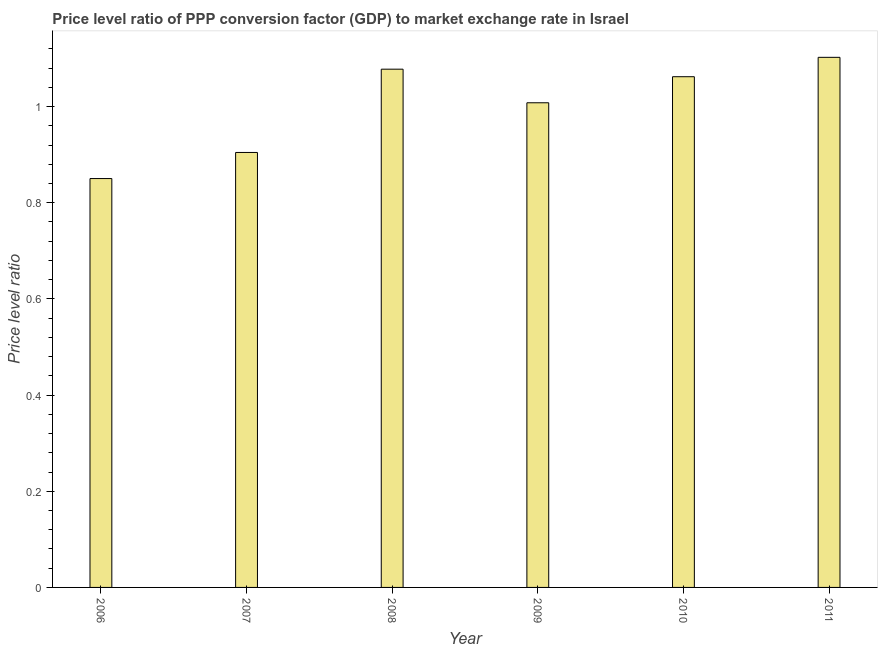Does the graph contain grids?
Provide a succinct answer. No. What is the title of the graph?
Give a very brief answer. Price level ratio of PPP conversion factor (GDP) to market exchange rate in Israel. What is the label or title of the Y-axis?
Give a very brief answer. Price level ratio. What is the price level ratio in 2009?
Offer a terse response. 1.01. Across all years, what is the maximum price level ratio?
Offer a terse response. 1.1. Across all years, what is the minimum price level ratio?
Your answer should be compact. 0.85. In which year was the price level ratio minimum?
Offer a very short reply. 2006. What is the sum of the price level ratio?
Ensure brevity in your answer.  6.01. What is the difference between the price level ratio in 2009 and 2011?
Your answer should be very brief. -0.1. What is the median price level ratio?
Offer a very short reply. 1.04. Do a majority of the years between 2009 and 2007 (inclusive) have price level ratio greater than 1 ?
Provide a short and direct response. Yes. What is the ratio of the price level ratio in 2006 to that in 2009?
Give a very brief answer. 0.84. Is the price level ratio in 2008 less than that in 2009?
Offer a terse response. No. Is the difference between the price level ratio in 2008 and 2011 greater than the difference between any two years?
Keep it short and to the point. No. What is the difference between the highest and the second highest price level ratio?
Provide a short and direct response. 0.03. What is the difference between the highest and the lowest price level ratio?
Make the answer very short. 0.25. How many bars are there?
Ensure brevity in your answer.  6. What is the difference between two consecutive major ticks on the Y-axis?
Offer a terse response. 0.2. What is the Price level ratio of 2006?
Offer a terse response. 0.85. What is the Price level ratio of 2007?
Give a very brief answer. 0.9. What is the Price level ratio in 2008?
Provide a short and direct response. 1.08. What is the Price level ratio in 2009?
Keep it short and to the point. 1.01. What is the Price level ratio in 2010?
Make the answer very short. 1.06. What is the Price level ratio in 2011?
Your answer should be very brief. 1.1. What is the difference between the Price level ratio in 2006 and 2007?
Make the answer very short. -0.05. What is the difference between the Price level ratio in 2006 and 2008?
Offer a very short reply. -0.23. What is the difference between the Price level ratio in 2006 and 2009?
Ensure brevity in your answer.  -0.16. What is the difference between the Price level ratio in 2006 and 2010?
Your answer should be very brief. -0.21. What is the difference between the Price level ratio in 2006 and 2011?
Provide a succinct answer. -0.25. What is the difference between the Price level ratio in 2007 and 2008?
Your response must be concise. -0.17. What is the difference between the Price level ratio in 2007 and 2009?
Provide a succinct answer. -0.1. What is the difference between the Price level ratio in 2007 and 2010?
Give a very brief answer. -0.16. What is the difference between the Price level ratio in 2007 and 2011?
Offer a terse response. -0.2. What is the difference between the Price level ratio in 2008 and 2009?
Ensure brevity in your answer.  0.07. What is the difference between the Price level ratio in 2008 and 2010?
Keep it short and to the point. 0.02. What is the difference between the Price level ratio in 2008 and 2011?
Offer a terse response. -0.02. What is the difference between the Price level ratio in 2009 and 2010?
Give a very brief answer. -0.05. What is the difference between the Price level ratio in 2009 and 2011?
Your response must be concise. -0.09. What is the difference between the Price level ratio in 2010 and 2011?
Make the answer very short. -0.04. What is the ratio of the Price level ratio in 2006 to that in 2007?
Provide a succinct answer. 0.94. What is the ratio of the Price level ratio in 2006 to that in 2008?
Provide a succinct answer. 0.79. What is the ratio of the Price level ratio in 2006 to that in 2009?
Ensure brevity in your answer.  0.84. What is the ratio of the Price level ratio in 2006 to that in 2010?
Ensure brevity in your answer.  0.8. What is the ratio of the Price level ratio in 2006 to that in 2011?
Keep it short and to the point. 0.77. What is the ratio of the Price level ratio in 2007 to that in 2008?
Provide a succinct answer. 0.84. What is the ratio of the Price level ratio in 2007 to that in 2009?
Ensure brevity in your answer.  0.9. What is the ratio of the Price level ratio in 2007 to that in 2010?
Your answer should be very brief. 0.85. What is the ratio of the Price level ratio in 2007 to that in 2011?
Make the answer very short. 0.82. What is the ratio of the Price level ratio in 2008 to that in 2009?
Ensure brevity in your answer.  1.07. What is the ratio of the Price level ratio in 2008 to that in 2010?
Your answer should be compact. 1.01. What is the ratio of the Price level ratio in 2008 to that in 2011?
Your answer should be very brief. 0.98. What is the ratio of the Price level ratio in 2009 to that in 2010?
Your answer should be compact. 0.95. What is the ratio of the Price level ratio in 2009 to that in 2011?
Your answer should be very brief. 0.91. 